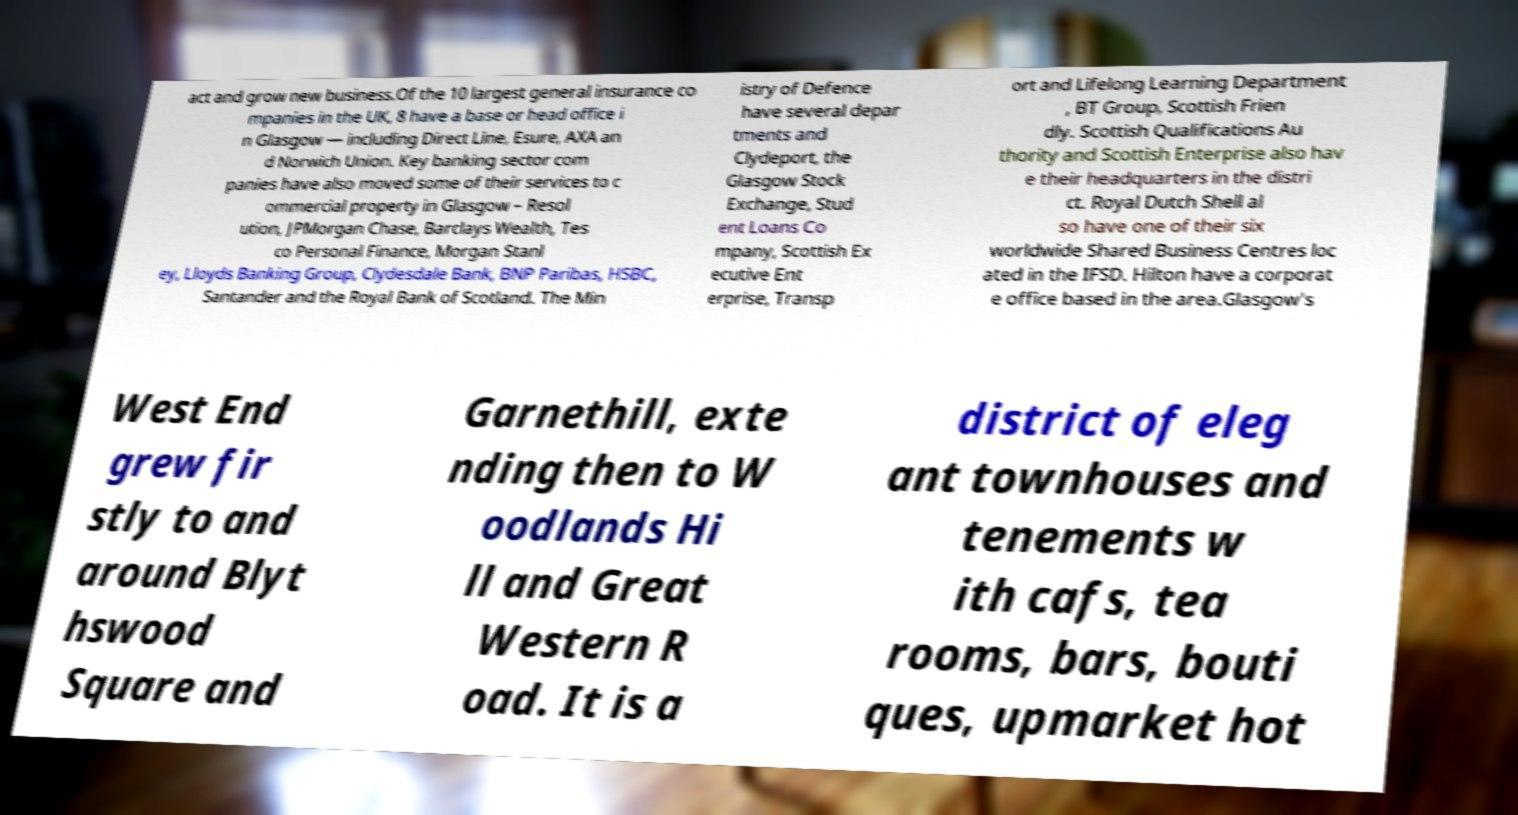Could you extract and type out the text from this image? act and grow new business.Of the 10 largest general insurance co mpanies in the UK, 8 have a base or head office i n Glasgow — including Direct Line, Esure, AXA an d Norwich Union. Key banking sector com panies have also moved some of their services to c ommercial property in Glasgow – Resol ution, JPMorgan Chase, Barclays Wealth, Tes co Personal Finance, Morgan Stanl ey, Lloyds Banking Group, Clydesdale Bank, BNP Paribas, HSBC, Santander and the Royal Bank of Scotland. The Min istry of Defence have several depar tments and Clydeport, the Glasgow Stock Exchange, Stud ent Loans Co mpany, Scottish Ex ecutive Ent erprise, Transp ort and Lifelong Learning Department , BT Group, Scottish Frien dly. Scottish Qualifications Au thority and Scottish Enterprise also hav e their headquarters in the distri ct. Royal Dutch Shell al so have one of their six worldwide Shared Business Centres loc ated in the IFSD. Hilton have a corporat e office based in the area.Glasgow's West End grew fir stly to and around Blyt hswood Square and Garnethill, exte nding then to W oodlands Hi ll and Great Western R oad. It is a district of eleg ant townhouses and tenements w ith cafs, tea rooms, bars, bouti ques, upmarket hot 